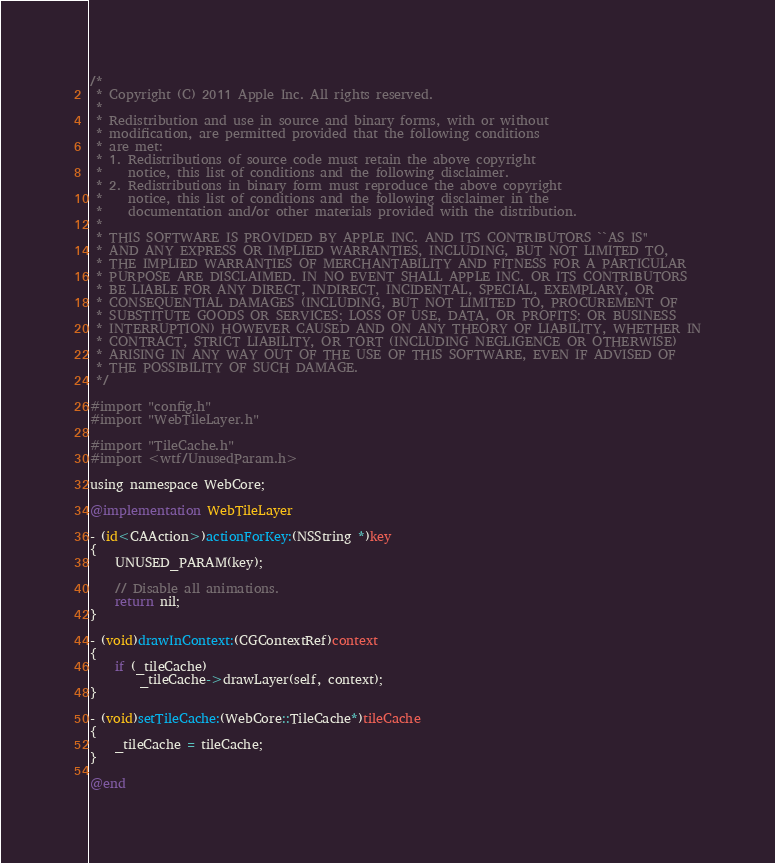<code> <loc_0><loc_0><loc_500><loc_500><_ObjectiveC_>/*
 * Copyright (C) 2011 Apple Inc. All rights reserved.
 *
 * Redistribution and use in source and binary forms, with or without
 * modification, are permitted provided that the following conditions
 * are met:
 * 1. Redistributions of source code must retain the above copyright
 *    notice, this list of conditions and the following disclaimer.
 * 2. Redistributions in binary form must reproduce the above copyright
 *    notice, this list of conditions and the following disclaimer in the
 *    documentation and/or other materials provided with the distribution.
 *
 * THIS SOFTWARE IS PROVIDED BY APPLE INC. AND ITS CONTRIBUTORS ``AS IS''
 * AND ANY EXPRESS OR IMPLIED WARRANTIES, INCLUDING, BUT NOT LIMITED TO,
 * THE IMPLIED WARRANTIES OF MERCHANTABILITY AND FITNESS FOR A PARTICULAR
 * PURPOSE ARE DISCLAIMED. IN NO EVENT SHALL APPLE INC. OR ITS CONTRIBUTORS
 * BE LIABLE FOR ANY DIRECT, INDIRECT, INCIDENTAL, SPECIAL, EXEMPLARY, OR
 * CONSEQUENTIAL DAMAGES (INCLUDING, BUT NOT LIMITED TO, PROCUREMENT OF
 * SUBSTITUTE GOODS OR SERVICES; LOSS OF USE, DATA, OR PROFITS; OR BUSINESS
 * INTERRUPTION) HOWEVER CAUSED AND ON ANY THEORY OF LIABILITY, WHETHER IN
 * CONTRACT, STRICT LIABILITY, OR TORT (INCLUDING NEGLIGENCE OR OTHERWISE)
 * ARISING IN ANY WAY OUT OF THE USE OF THIS SOFTWARE, EVEN IF ADVISED OF
 * THE POSSIBILITY OF SUCH DAMAGE.
 */

#import "config.h"
#import "WebTileLayer.h"

#import "TileCache.h"
#import <wtf/UnusedParam.h>

using namespace WebCore;

@implementation WebTileLayer

- (id<CAAction>)actionForKey:(NSString *)key
{
    UNUSED_PARAM(key);
    
    // Disable all animations.
    return nil;
}

- (void)drawInContext:(CGContextRef)context
{
    if (_tileCache)
        _tileCache->drawLayer(self, context);
}

- (void)setTileCache:(WebCore::TileCache*)tileCache
{
    _tileCache = tileCache;
}

@end

</code> 